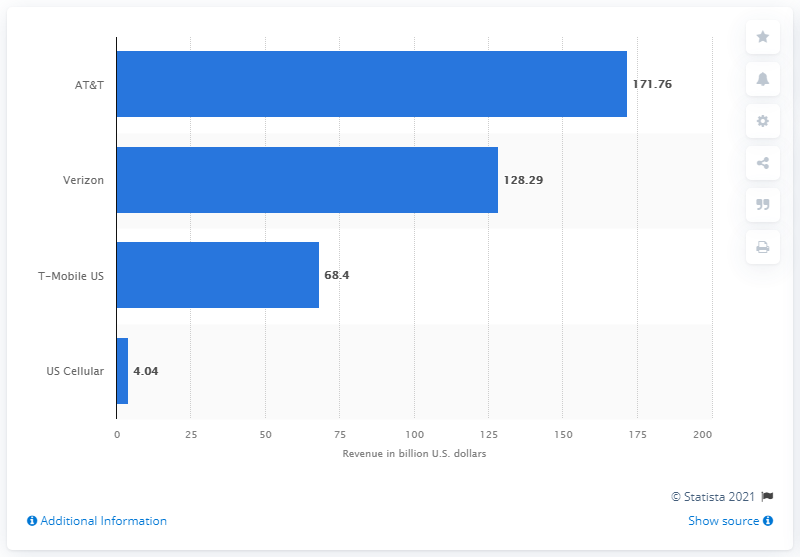Point out several critical features in this image. In 2020, AT&T generated a total revenue of 171.76 billion dollars. 